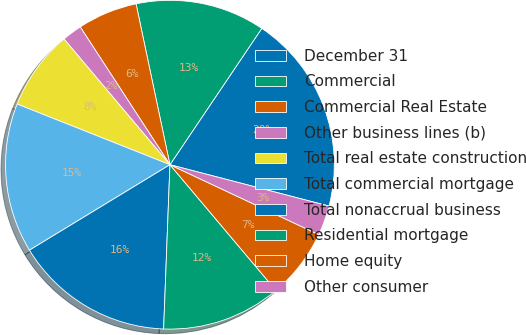Convert chart to OTSL. <chart><loc_0><loc_0><loc_500><loc_500><pie_chart><fcel>December 31<fcel>Commercial<fcel>Commercial Real Estate<fcel>Other business lines (b)<fcel>Total real estate construction<fcel>Total commercial mortgage<fcel>Total nonaccrual business<fcel>Residential mortgage<fcel>Home equity<fcel>Other consumer<nl><fcel>19.61%<fcel>12.74%<fcel>5.88%<fcel>1.96%<fcel>7.84%<fcel>14.71%<fcel>15.69%<fcel>11.76%<fcel>6.86%<fcel>2.94%<nl></chart> 